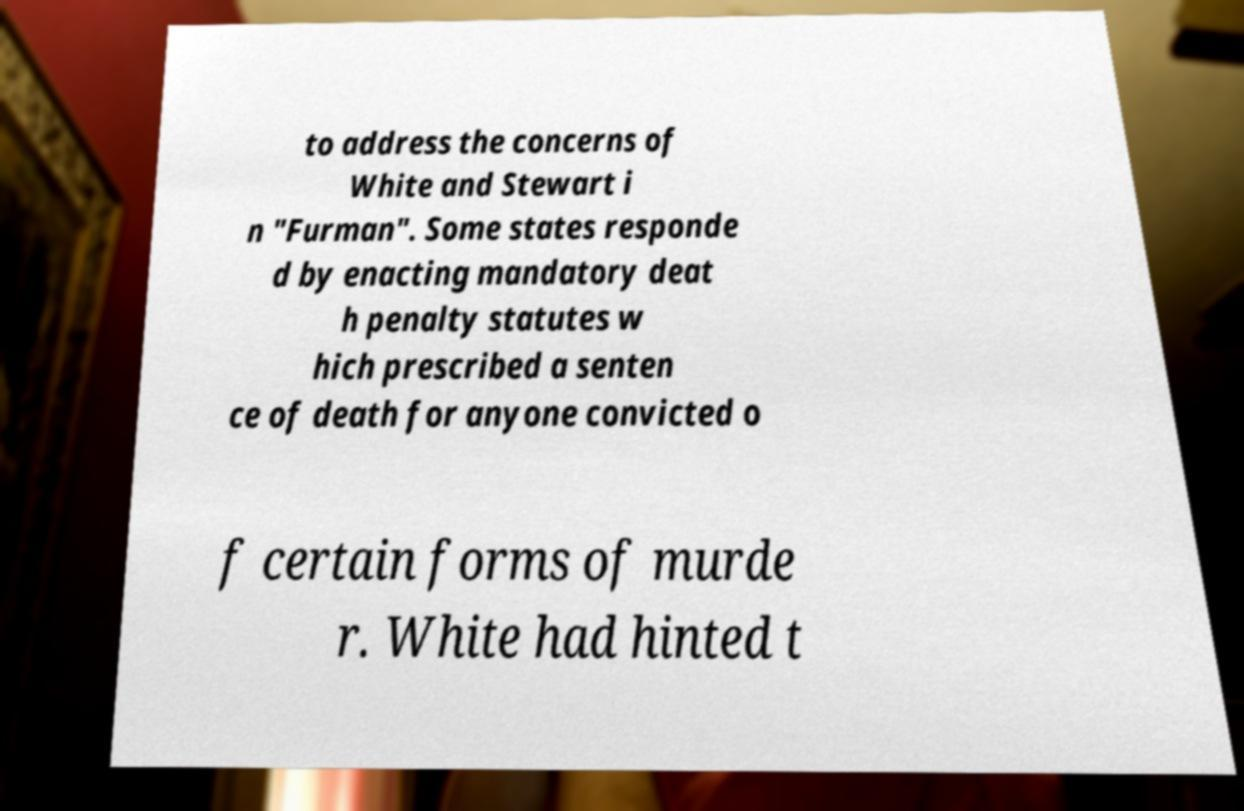I need the written content from this picture converted into text. Can you do that? to address the concerns of White and Stewart i n "Furman". Some states responde d by enacting mandatory deat h penalty statutes w hich prescribed a senten ce of death for anyone convicted o f certain forms of murde r. White had hinted t 